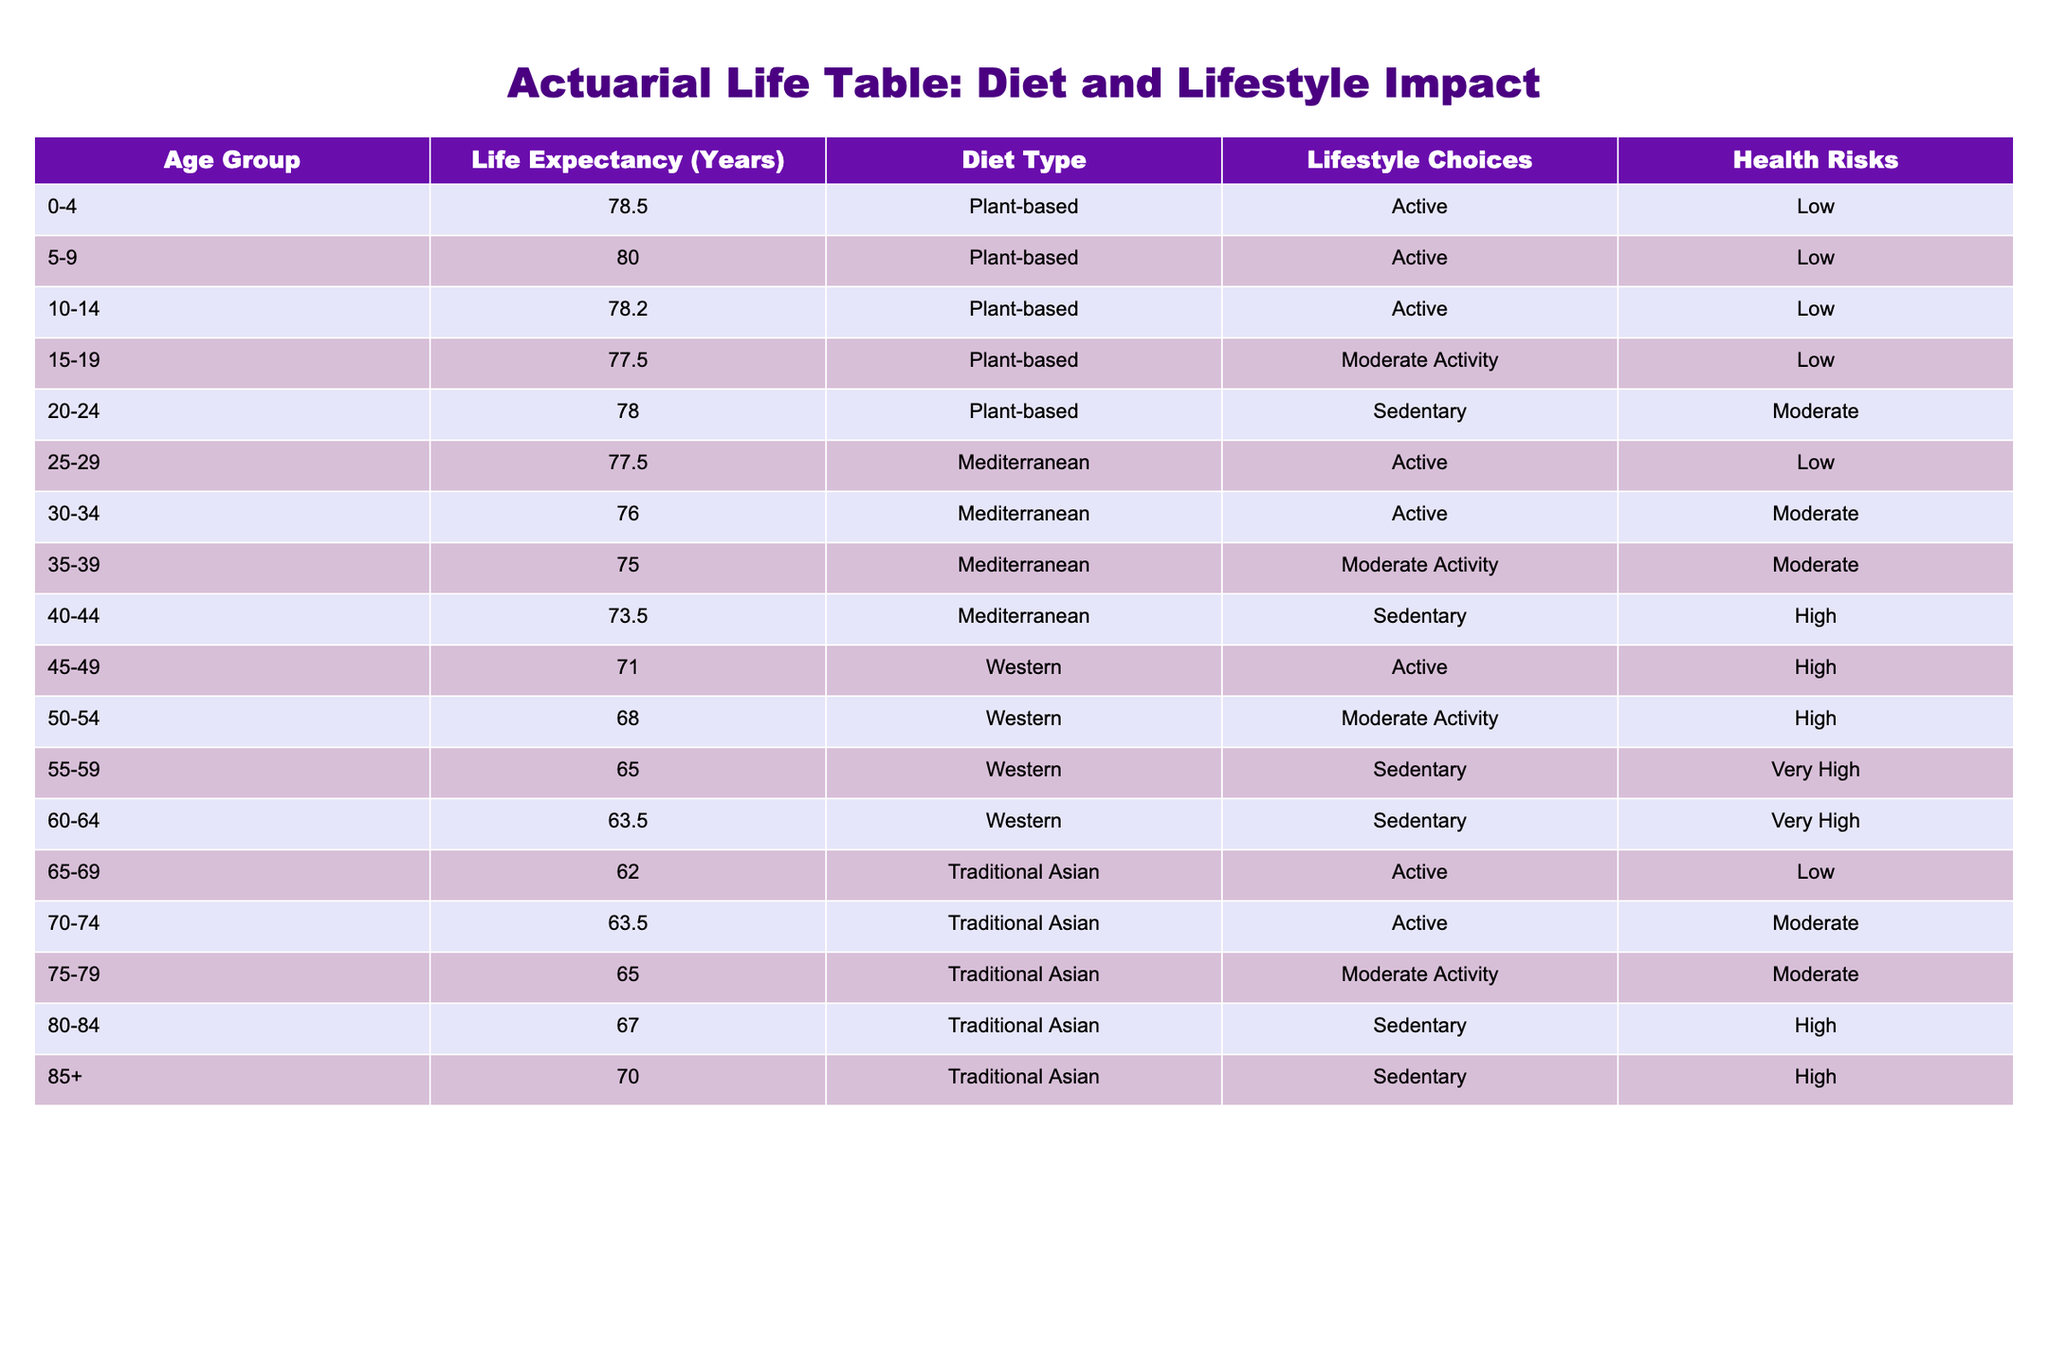What is the life expectancy for the age group 60-64? From the table, we can directly find the entry for the age group 60-64, which states the life expectancy is 63.5 years.
Answer: 63.5 Which diet type corresponds to the highest life expectancy in the age group 0-4? The age group 0-4 has a life expectancy of 78.5 years, and this is associated with the Plant-based diet, which is clearly indicated in the table.
Answer: Plant-based What is the life expectancy difference between the age groups 55-59 and 65-69? The life expectancy for the age group 55-59 is 65.0 years, while for 65-69 it is 62.0 years. The difference can be calculated as 65.0 - 62.0 = 3.0 years.
Answer: 3.0 Is the life expectancy for the Traditional Asian diet higher for the age group 75-79 compared to the 80-84 age group? The life expectancy for 75-79 is 65.0 years, and for 80-84 it is 67.0 years. Since 67.0 is greater than 65.0, the statement is false.
Answer: No What is the average life expectancy for individuals aged 25-29 and 30-34? For individuals aged 25-29 the life expectancy is 77.5 years and for 30-34 it is 76.0 years. To find the average: (77.5 + 76.0) / 2 = 76.75 years.
Answer: 76.75 Considering all groups, how many age groups with a Mediterranean diet reflect a life expectancy below 75 years? From the table, the age groups that have a Mediterranean diet and life expectancy below 75 years are 35-39 (75.0), 40-44 (73.5). Thus, only 40-44 is below 75 years. This means there is one such age group.
Answer: 1 What is the total life expectancy for the age group 20-24, adding the values from each lifestyle choice? The age group 20-24 has a life expectancy of 78.0 years for a sedentary lifestyle. To find the total, only this single value is considered since there are no other age groups listed for 20-24. Thus, the total for this group is simply 78.0.
Answer: 78.0 Does an active lifestyle lead to a higher life expectancy amongst the Plant-based diet categories? Yes, all the Plant-based entries with active or moderate activity lifestyle choices have higher life expectancies, with the lowest being 77.5 for 15-19, confirming that active lifestyles within the Plant-based category generally have a higher expectancy.
Answer: Yes 